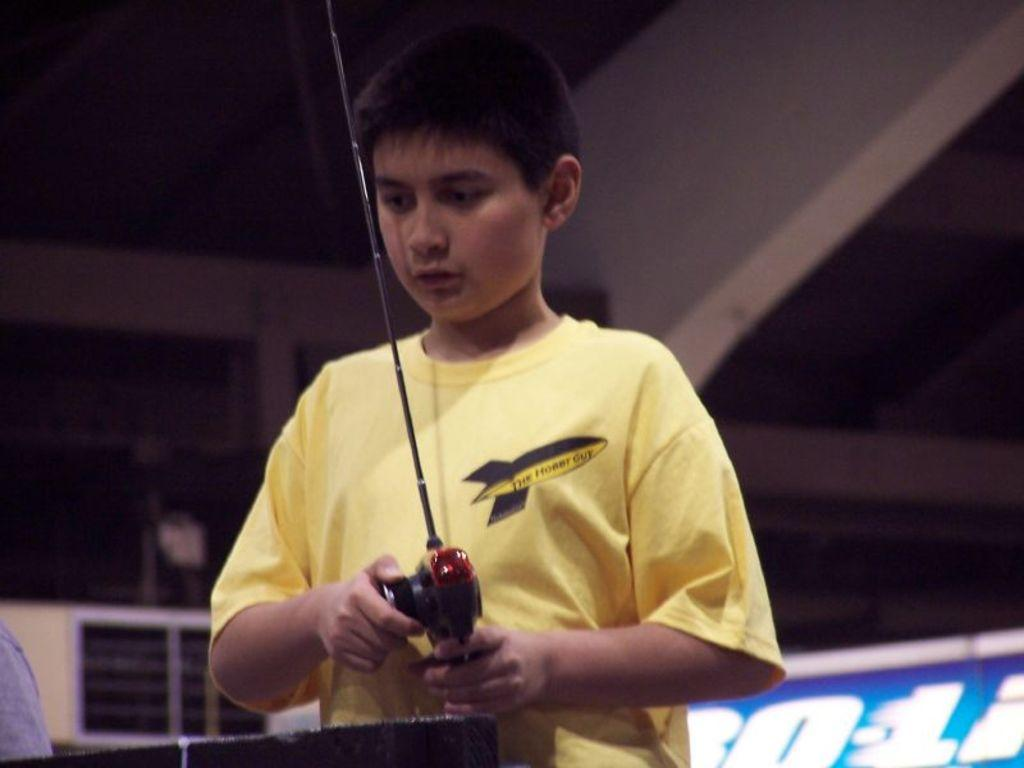What is the main subject of the image? There is a boy standing in the middle of the image. What is the boy holding in his hand? The boy is holding something in his hand, but the specific object is not mentioned in the facts. What can be seen behind the boy? There is a wall behind the boy. What part of the room is visible at the top of the image? The ceiling is visible at the top of the image. What type of jewel is the boy wearing around his neck in the image? There is no mention of a jewel in the image, so it cannot be determined if the boy is wearing one. 